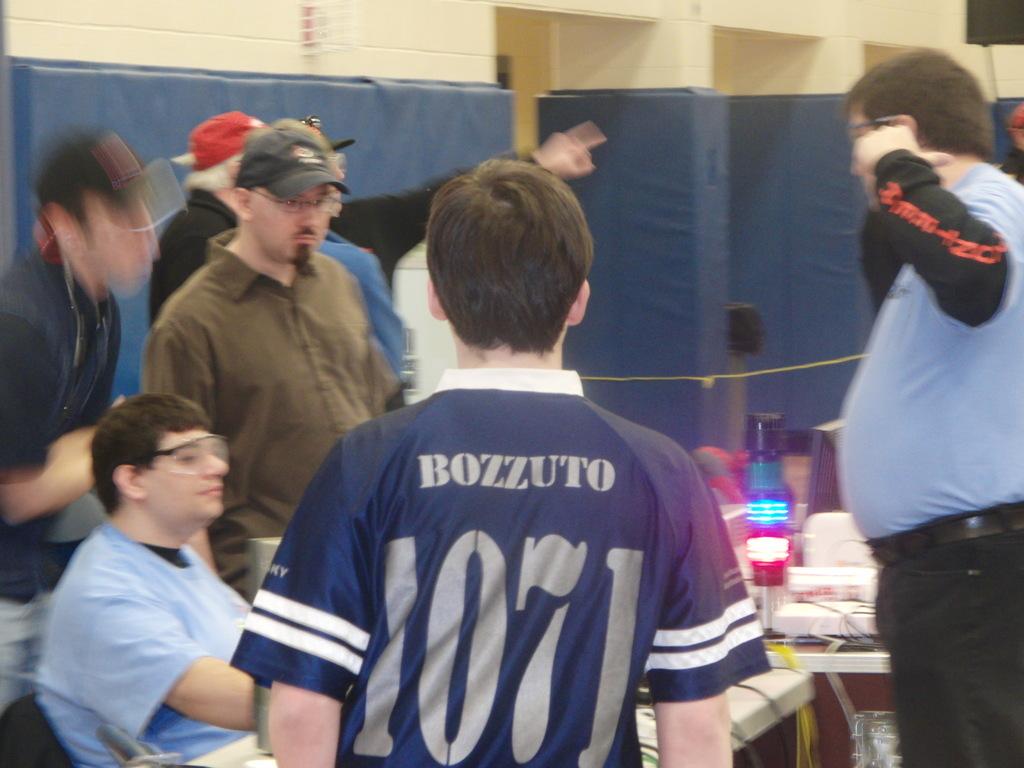What is the number of bozzuto?
Ensure brevity in your answer.  1071. What name is on the back of the shirt in the middle?
Offer a very short reply. Bozzuto. 